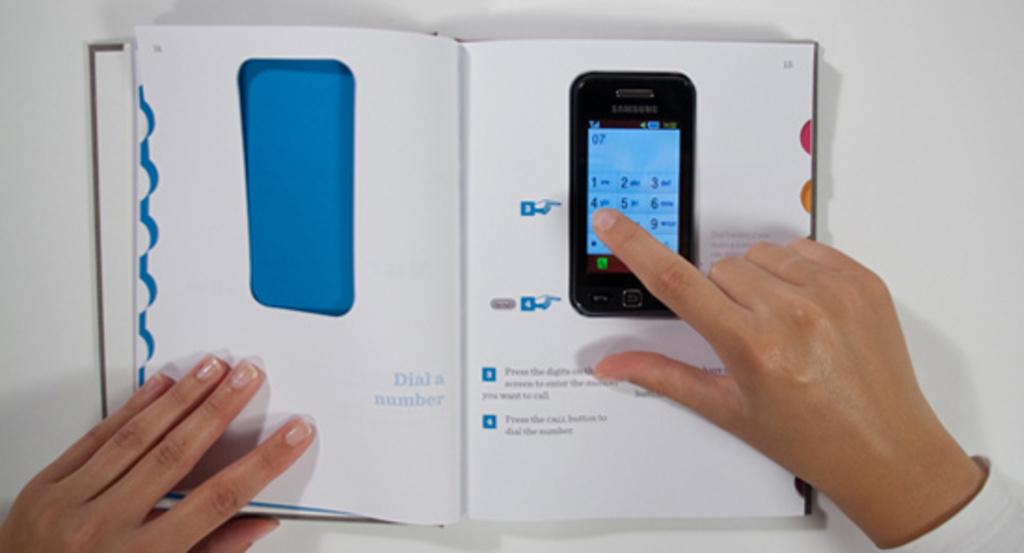<image>
Summarize the visual content of the image. A hand hovers over the 4 of a Samsung phone. 